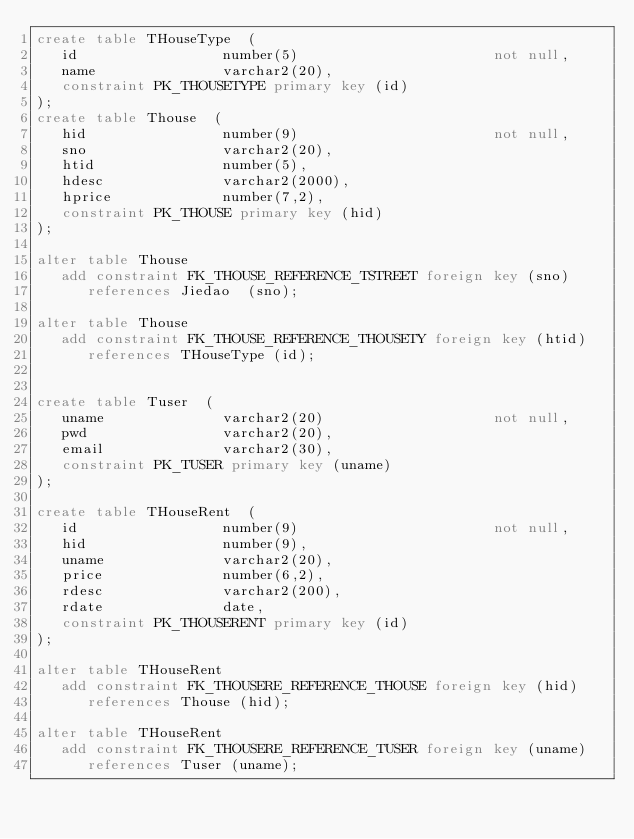<code> <loc_0><loc_0><loc_500><loc_500><_SQL_>create table THouseType  (
   id                 number(5)                       not null,
   name               varchar2(20),
   constraint PK_THOUSETYPE primary key (id)
);
create table Thouse  (
   hid                number(9)                       not null,
   sno                varchar2(20),
   htid               number(5),
   hdesc              varchar2(2000),
   hprice             number(7,2),
   constraint PK_THOUSE primary key (hid)
);

alter table Thouse
   add constraint FK_THOUSE_REFERENCE_TSTREET foreign key (sno)
      references Jiedao  (sno);

alter table Thouse
   add constraint FK_THOUSE_REFERENCE_THOUSETY foreign key (htid)
      references THouseType (id);


create table Tuser  (
   uname              varchar2(20)                    not null,
   pwd                varchar2(20),
   email              varchar2(30),
   constraint PK_TUSER primary key (uname)
);

create table THouseRent  (
   id                 number(9)                       not null,
   hid                number(9),
   uname              varchar2(20),
   price              number(6,2),
   rdesc              varchar2(200),
   rdate              date,
   constraint PK_THOUSERENT primary key (id)
);

alter table THouseRent
   add constraint FK_THOUSERE_REFERENCE_THOUSE foreign key (hid)
      references Thouse (hid);

alter table THouseRent
   add constraint FK_THOUSERE_REFERENCE_TUSER foreign key (uname)
      references Tuser (uname);

</code> 